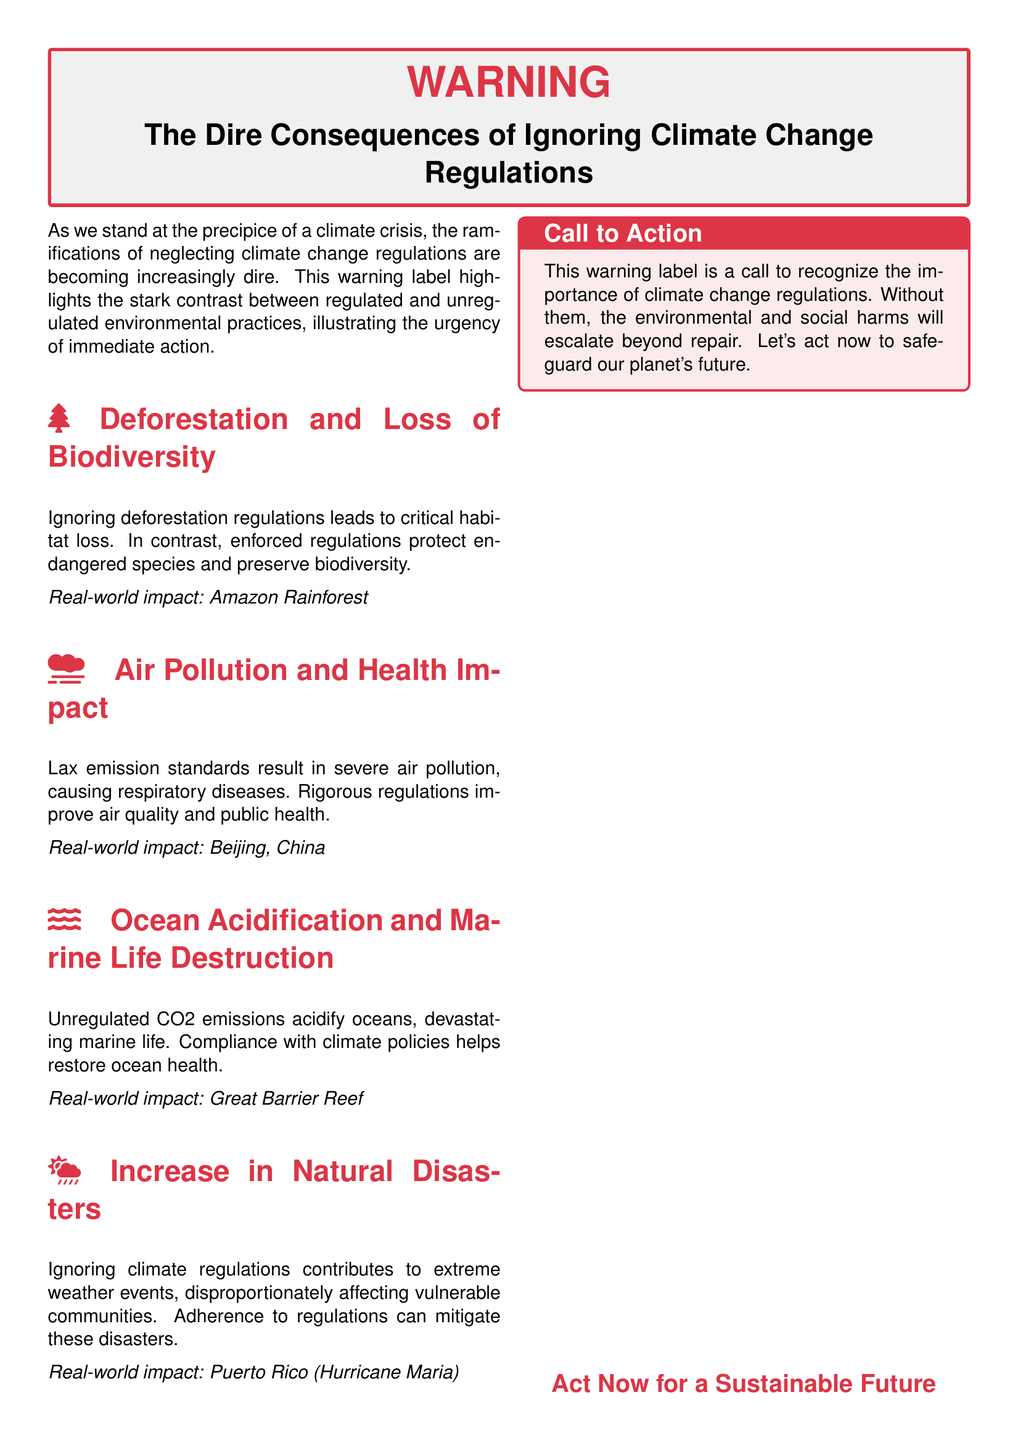What is the main title of the document? The main title is prominently displayed at the top of the document, indicating the focus on climate change regulations.
Answer: The Dire Consequences of Ignoring Climate Change Regulations What significant environmental issue is highlighted under the section "Deforestation and Loss of Biodiversity"? This section specifically addresses the impact of deforestation and how regulations help protect endangered species.
Answer: Habitat loss What city is mentioned in relation to air pollution? The document refers to a specific city known for its air quality challenges that relate to the section on air pollution.
Answer: Beijing What marine ecosystem is referenced concerning ocean acidification? The text discusses a well-known marine ecosystem used as a case study for the effects of unregulated emissions on ocean health.
Answer: Great Barrier Reef How does ignoring climate regulations affect natural disasters? The document states that neglecting climate regulations contributes to an increase in extreme weather events.
Answer: Extreme weather events What is the call to action in the document? The document closes with a clear directive urging readers to recognize the importance of climate regulations.
Answer: Act now to safeguard our planet's future What icon represents the section on air pollution? The document uses a specific symbol to illustrate the section concerned with air quality issues.
Answer: Smog How does the document describe the overall impact of climate change regulations? The document implies a positive outcome when climate change regulations are enforced, specifically related to environmental health.
Answer: Restoration of health 